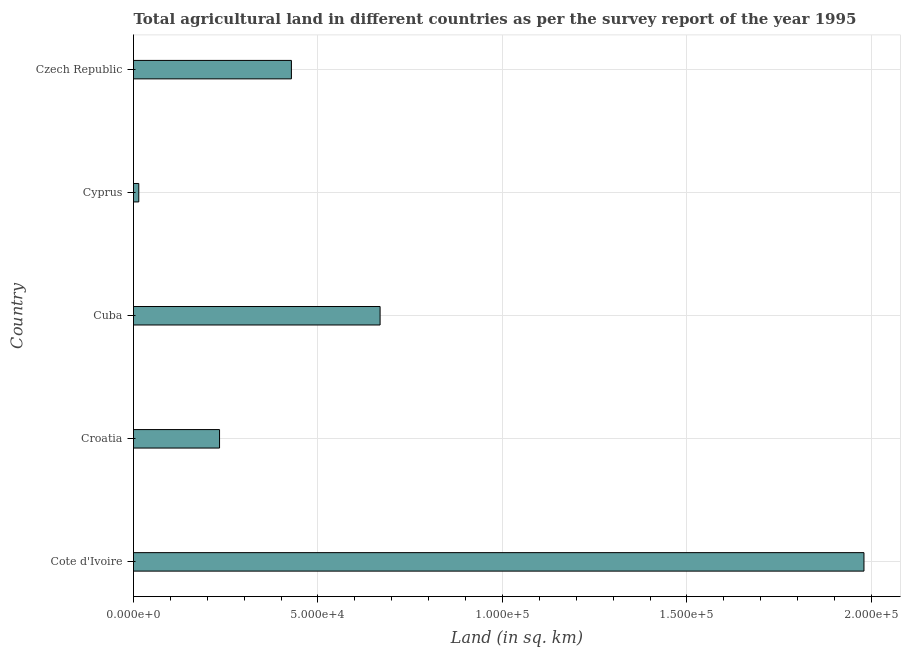Does the graph contain grids?
Offer a terse response. Yes. What is the title of the graph?
Offer a very short reply. Total agricultural land in different countries as per the survey report of the year 1995. What is the label or title of the X-axis?
Make the answer very short. Land (in sq. km). What is the agricultural land in Czech Republic?
Provide a succinct answer. 4.28e+04. Across all countries, what is the maximum agricultural land?
Your answer should be compact. 1.98e+05. Across all countries, what is the minimum agricultural land?
Your response must be concise. 1431. In which country was the agricultural land maximum?
Your answer should be very brief. Cote d'Ivoire. In which country was the agricultural land minimum?
Your response must be concise. Cyprus. What is the sum of the agricultural land?
Your response must be concise. 3.32e+05. What is the difference between the agricultural land in Cote d'Ivoire and Croatia?
Your response must be concise. 1.75e+05. What is the average agricultural land per country?
Offer a terse response. 6.65e+04. What is the median agricultural land?
Give a very brief answer. 4.28e+04. What is the ratio of the agricultural land in Cuba to that in Cyprus?
Give a very brief answer. 46.71. What is the difference between the highest and the second highest agricultural land?
Your answer should be compact. 1.31e+05. Is the sum of the agricultural land in Croatia and Cuba greater than the maximum agricultural land across all countries?
Your response must be concise. No. What is the difference between the highest and the lowest agricultural land?
Your answer should be compact. 1.97e+05. How many bars are there?
Ensure brevity in your answer.  5. How many countries are there in the graph?
Keep it short and to the point. 5. Are the values on the major ticks of X-axis written in scientific E-notation?
Your answer should be compact. Yes. What is the Land (in sq. km) in Cote d'Ivoire?
Provide a short and direct response. 1.98e+05. What is the Land (in sq. km) of Croatia?
Ensure brevity in your answer.  2.33e+04. What is the Land (in sq. km) in Cuba?
Keep it short and to the point. 6.68e+04. What is the Land (in sq. km) in Cyprus?
Your response must be concise. 1431. What is the Land (in sq. km) in Czech Republic?
Provide a short and direct response. 4.28e+04. What is the difference between the Land (in sq. km) in Cote d'Ivoire and Croatia?
Your answer should be very brief. 1.75e+05. What is the difference between the Land (in sq. km) in Cote d'Ivoire and Cuba?
Make the answer very short. 1.31e+05. What is the difference between the Land (in sq. km) in Cote d'Ivoire and Cyprus?
Provide a short and direct response. 1.97e+05. What is the difference between the Land (in sq. km) in Cote d'Ivoire and Czech Republic?
Make the answer very short. 1.55e+05. What is the difference between the Land (in sq. km) in Croatia and Cuba?
Your response must be concise. -4.35e+04. What is the difference between the Land (in sq. km) in Croatia and Cyprus?
Your answer should be very brief. 2.19e+04. What is the difference between the Land (in sq. km) in Croatia and Czech Republic?
Make the answer very short. -1.95e+04. What is the difference between the Land (in sq. km) in Cuba and Cyprus?
Provide a short and direct response. 6.54e+04. What is the difference between the Land (in sq. km) in Cuba and Czech Republic?
Your answer should be very brief. 2.40e+04. What is the difference between the Land (in sq. km) in Cyprus and Czech Republic?
Ensure brevity in your answer.  -4.14e+04. What is the ratio of the Land (in sq. km) in Cote d'Ivoire to that in Croatia?
Provide a short and direct response. 8.49. What is the ratio of the Land (in sq. km) in Cote d'Ivoire to that in Cuba?
Your answer should be very brief. 2.96. What is the ratio of the Land (in sq. km) in Cote d'Ivoire to that in Cyprus?
Your response must be concise. 138.37. What is the ratio of the Land (in sq. km) in Cote d'Ivoire to that in Czech Republic?
Your answer should be compact. 4.63. What is the ratio of the Land (in sq. km) in Croatia to that in Cuba?
Give a very brief answer. 0.35. What is the ratio of the Land (in sq. km) in Croatia to that in Cyprus?
Keep it short and to the point. 16.3. What is the ratio of the Land (in sq. km) in Croatia to that in Czech Republic?
Make the answer very short. 0.55. What is the ratio of the Land (in sq. km) in Cuba to that in Cyprus?
Provide a short and direct response. 46.71. What is the ratio of the Land (in sq. km) in Cuba to that in Czech Republic?
Make the answer very short. 1.56. What is the ratio of the Land (in sq. km) in Cyprus to that in Czech Republic?
Give a very brief answer. 0.03. 